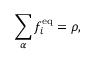Convert formula to latex. <formula><loc_0><loc_0><loc_500><loc_500>\sum _ { \alpha } f _ { i } ^ { e q } = \rho ,</formula> 